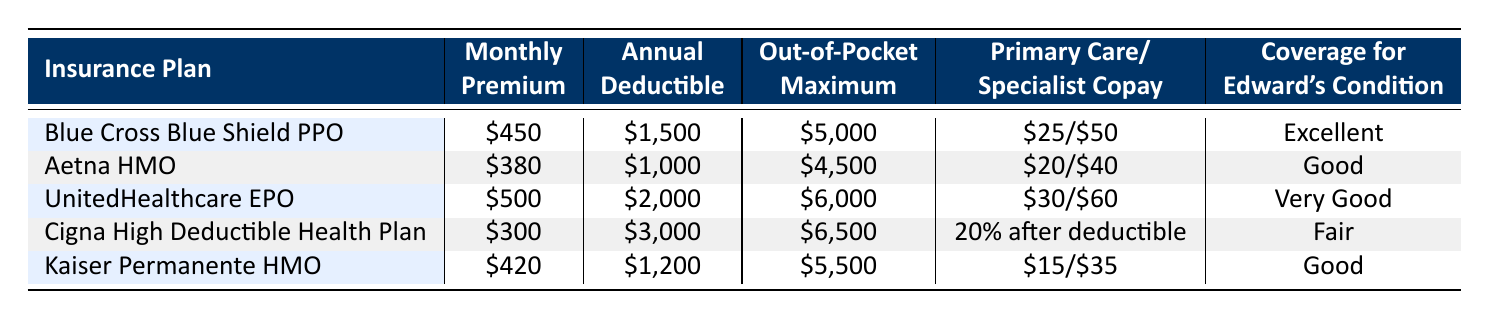What is the monthly premium for the Blue Cross Blue Shield PPO plan? The table lists the monthly premium for the Blue Cross Blue Shield PPO plan as $450.
Answer: $450 Which insurance plan has the highest annual deductible? By comparing the annual deductibles, the UnitedHealthcare EPO has the highest annual deductible at $2,000.
Answer: UnitedHealthcare EPO Is the out-of-pocket maximum for Aetna HMO less than that of Kaiser Permanente HMO? The out-of-pocket maximum for Aetna HMO is $4,500, while Kaiser Permanente HMO has a maximum of $5,500. Since $4,500 is less than $5,500, the statement is true.
Answer: Yes What is the average monthly premium for the listed insurance plans? To find the average monthly premium, sum the premiums: $450 + $380 + $500 + $300 + $420 = $2050. Then, divide by the number of plans (5): 2050 / 5 = $410.
Answer: $410 Which plan has the best coverage for Edward's condition according to the table? According to the table, the coverage for Edward's condition is rated as "Excellent" for the Blue Cross Blue Shield PPO plan, which is the best coverage among all listed plans.
Answer: Blue Cross Blue Shield PPO Is there any insurance plan that has a primary care copay of $15? Checking the primary care copays listed, only the Kaiser Permanente HMO has a primary care copay of $15. Therefore, the statement is true.
Answer: Yes What are the prescription coverage costs for Tier 1 under the UnitedHealthcare EPO? The prescription coverage for Tier 1 under the UnitedHealthcare EPO is $5 as listed in the table.
Answer: $5 How much more is the monthly premium of UnitedHealthcare EPO compared to Cigna High Deductible Health Plan? The monthly premium for UnitedHealthcare EPO is $500, and for Cigna High Deductible Health Plan, it is $300. The difference is $500 - $300 = $200.
Answer: $200 Which insurance plan has a higher copay for a specialist visit, Aetna HMO or Kaiser Permanente HMO? Aetna HMO has a specialist copay of $40, while Kaiser Permanente HMO has a copay of $35. Therefore, Aetna HMO has the higher copay for a specialist visit.
Answer: Aetna HMO 